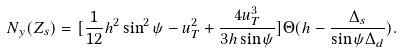Convert formula to latex. <formula><loc_0><loc_0><loc_500><loc_500>N _ { y } ( Z _ { s } ) = [ \frac { 1 } { 1 2 } h ^ { 2 } \sin ^ { 2 } \psi - u _ { T } ^ { 2 } + \frac { 4 u _ { T } ^ { 3 } } { 3 h \sin \psi } ] \Theta ( h - \frac { \Delta _ { s } } { \sin \psi \Delta _ { d } } ) .</formula> 